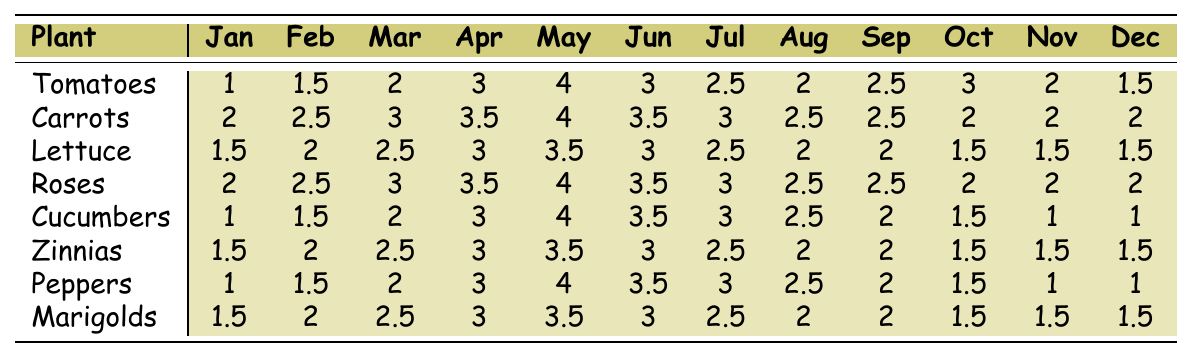What is the rainfall amount for Tomatoes in May? The table shows that the value for Tomatoes under May is 4.
Answer: 4 Which plant receives the most rainfall in February? By comparing the values in the February column, Carrots have the highest rainfall amount of 2.5.
Answer: Carrots What is the total rainfall for Lettuce during the months of April, May, and June? The rainfall amounts for Lettuce in those months are 3 (April), 3.5 (May), and 3 (June). Summing these gives 3 + 3.5 + 3 = 9.5.
Answer: 9.5 Do Peppers receive the same amount of rainfall in December as Cucumbers? Looking at the December column, Peppers receive 1 and Cucumbers also receive 1, thus they are equal.
Answer: Yes Which plant has the highest average rainfall across all months? First, I need to sum the rainfall amounts for each plant: Tomatoes (24), Carrots (30), Lettuce (25.5), Roses (30), Cucumbers (23), Zinnias (25.5), Peppers (23.5), and Marigolds (25.5). Next, I calculate the average for each plant, Carrots and Roses both have the highest total of 30. Thus the average is 30/12 = 2.5.
Answer: Carrots and Roses What is the difference in rainfall amounts between the highest and lowest months for Zinnias? The highest month is May with 3.5 and the lowest month is January with 1.5. The difference is 3.5 - 1.5 = 2.
Answer: 2 How many plants receive more than 3 units of rainfall in April? In April, the rainfall values are 3 for Tomatoes, 3.5 for Carrots and Lettuce, and 4 for Roses. Counting these, we find 4 (Roses) receives more than 3 units.
Answer: 4 Is the rainfall for Marigolds in October greater than that of Lettuce in September? The rainfall amounts are 1.5 for Marigolds in October and 2 for Lettuce in September, indicating that Marigolds receive less.
Answer: No What is the average rainfall for Cucumbers over the year? First, I sum the rainfall amounts for Cucumbers: 1 + 1.5 + 2 + 3 + 4 + 3.5 + 3 + 2.5 + 2 + 1.5 + 1 + 1 = 24. Then, I divide by 12, resulting in an average of 2.
Answer: 2 Which month has the least amount of rainfall for Lettuce? Checking the table, the lowest value for Lettuce occurs in both November and December where it is 1.5.
Answer: November and December 